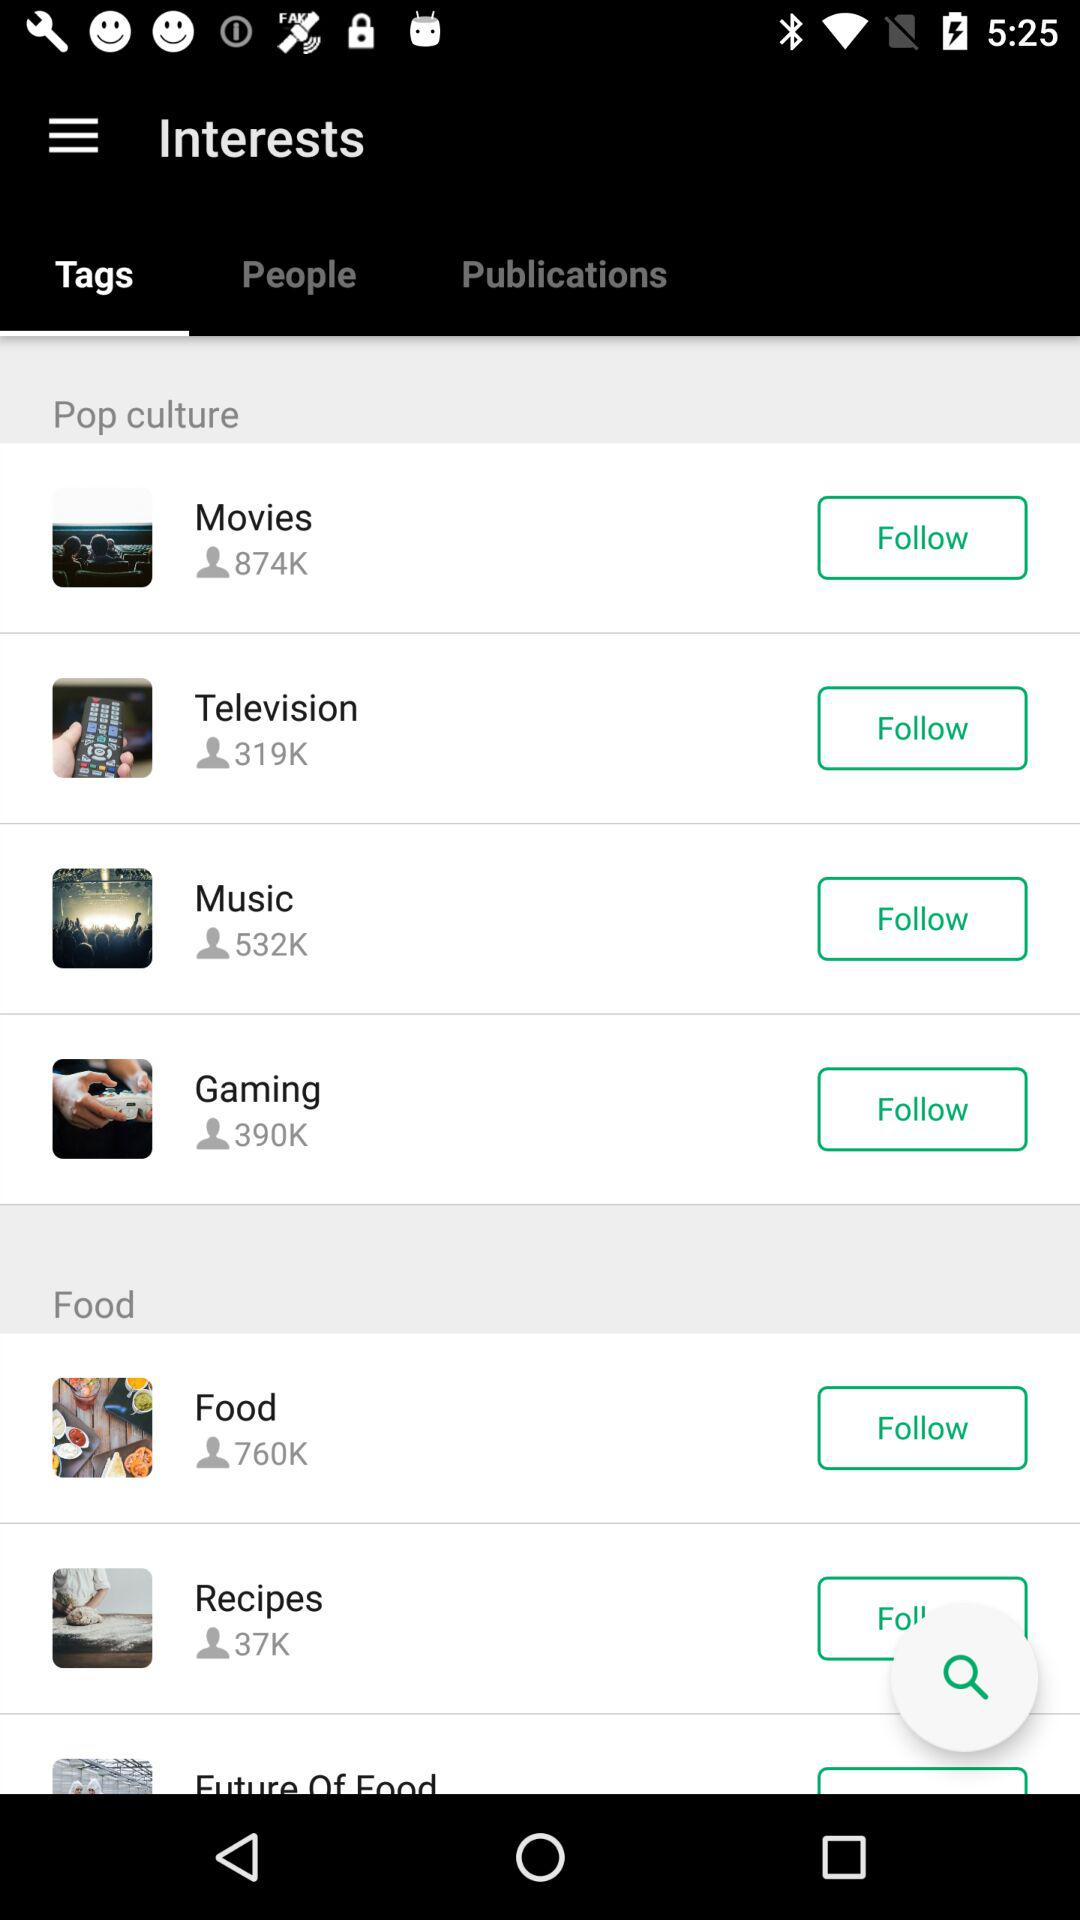How many people are interested in movies? There are 874,000 people interested in movies. 